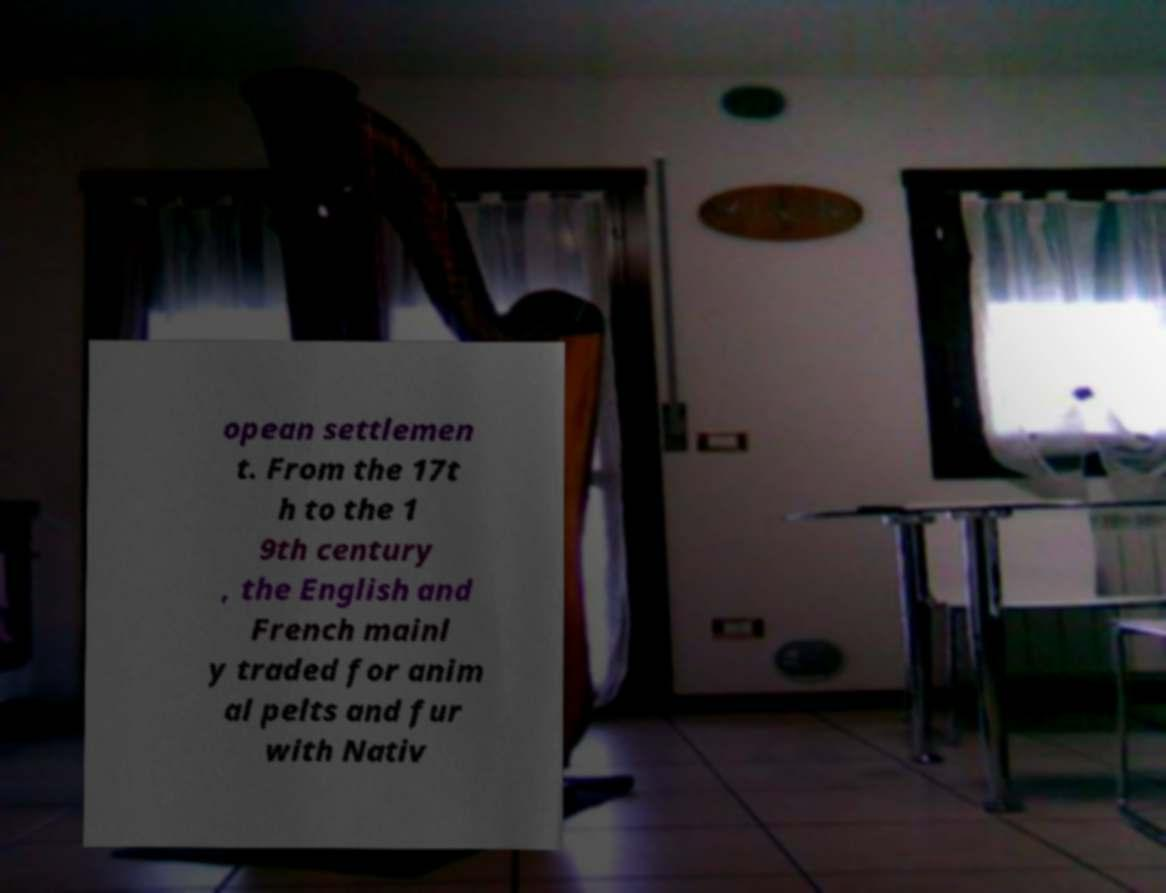Please read and relay the text visible in this image. What does it say? opean settlemen t. From the 17t h to the 1 9th century , the English and French mainl y traded for anim al pelts and fur with Nativ 